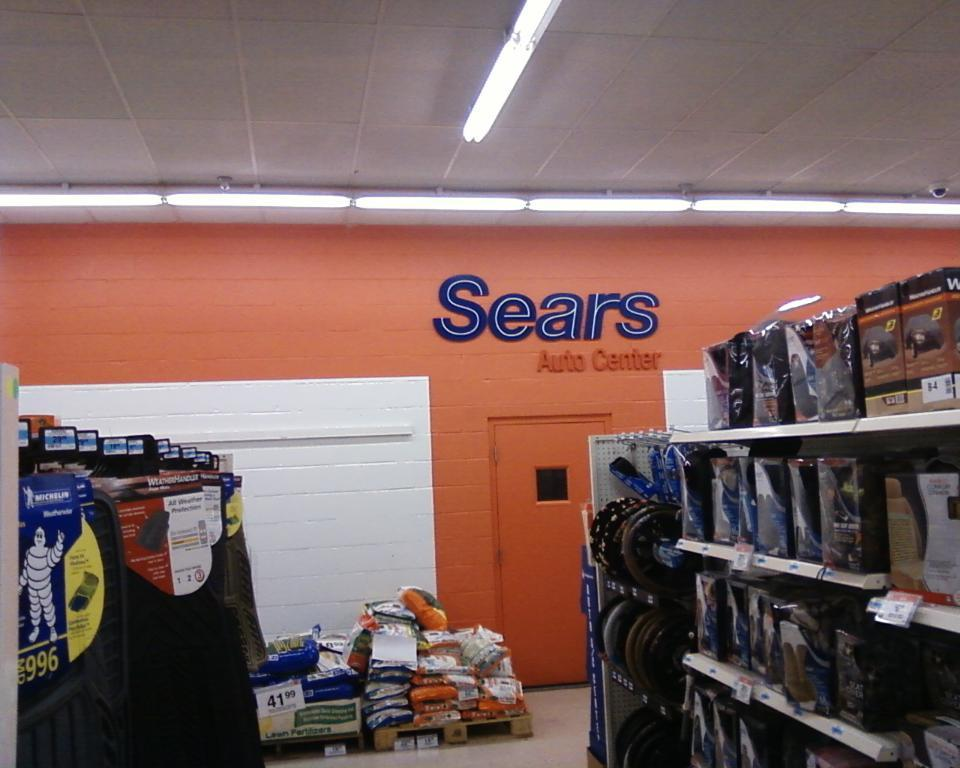<image>
Describe the image concisely. shelves of seatcovers  and floormats at sears auto center 